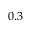Convert formula to latex. <formula><loc_0><loc_0><loc_500><loc_500>0 . 3</formula> 